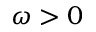<formula> <loc_0><loc_0><loc_500><loc_500>\omega > 0</formula> 